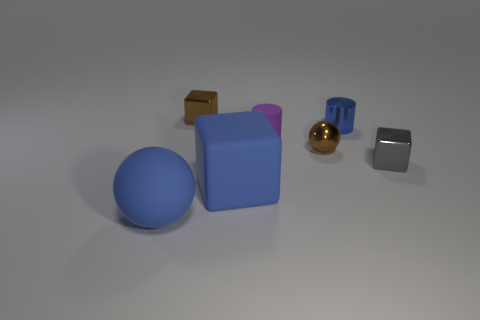Add 1 brown balls. How many objects exist? 8 Subtract all blocks. How many objects are left? 4 Add 3 small purple matte objects. How many small purple matte objects are left? 4 Add 4 tiny shiny blocks. How many tiny shiny blocks exist? 6 Subtract 0 cyan blocks. How many objects are left? 7 Subtract all brown objects. Subtract all tiny cyan things. How many objects are left? 5 